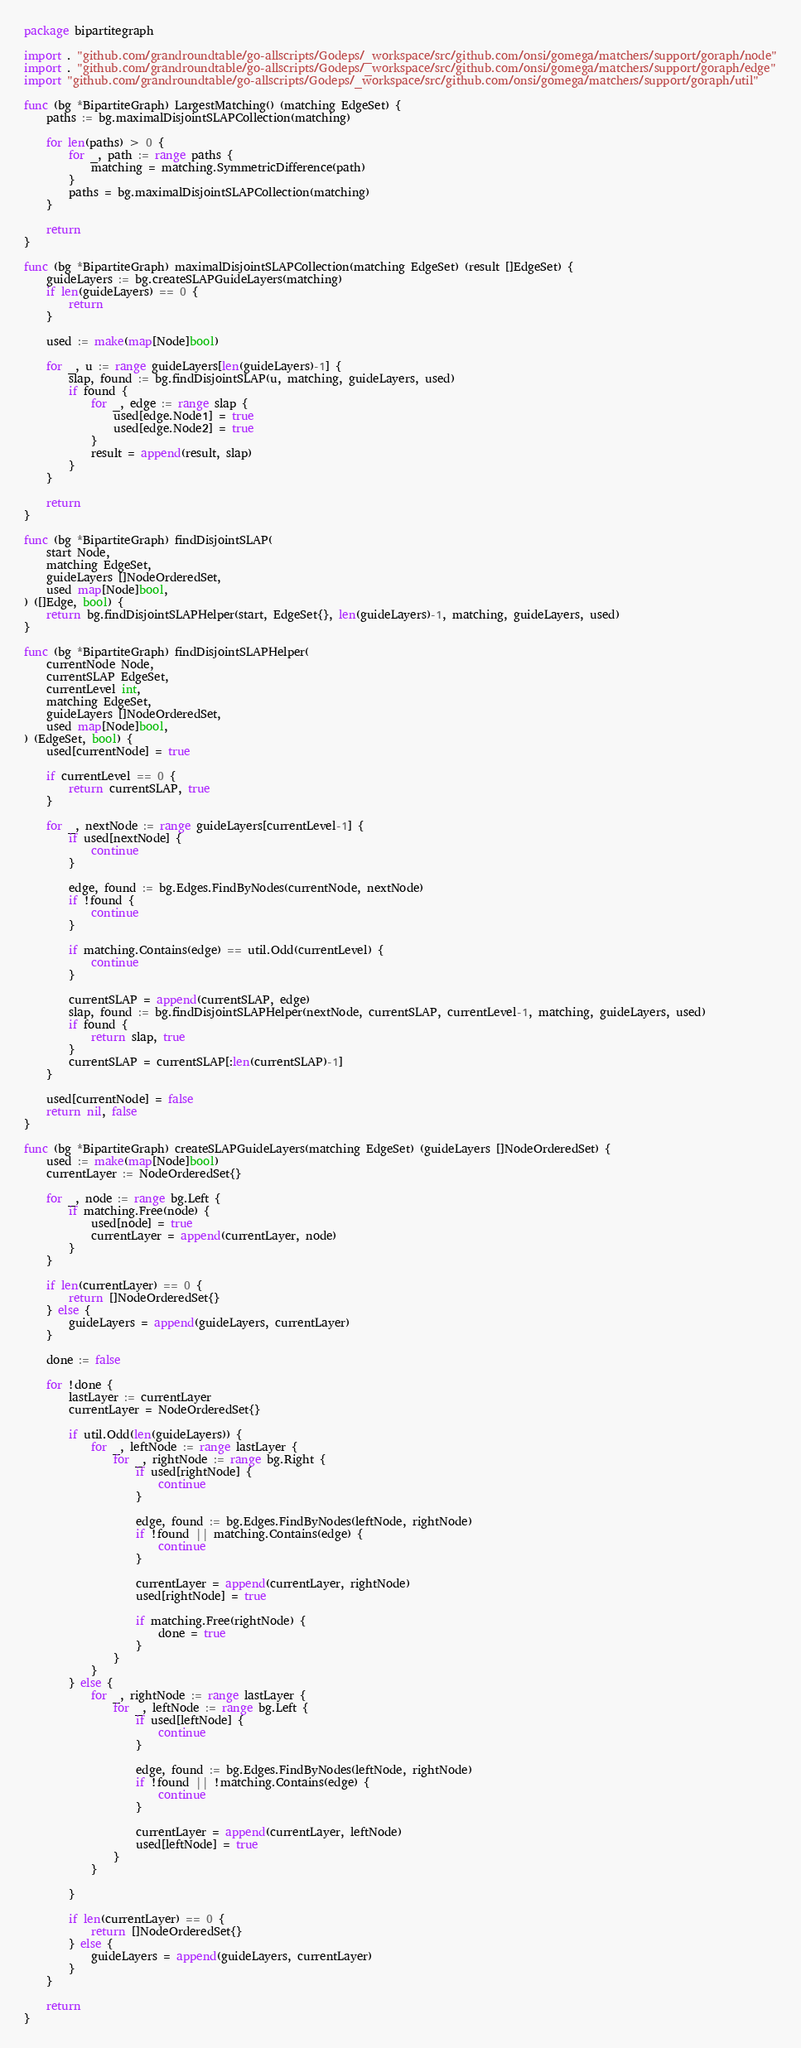Convert code to text. <code><loc_0><loc_0><loc_500><loc_500><_Go_>package bipartitegraph

import . "github.com/grandroundtable/go-allscripts/Godeps/_workspace/src/github.com/onsi/gomega/matchers/support/goraph/node"
import . "github.com/grandroundtable/go-allscripts/Godeps/_workspace/src/github.com/onsi/gomega/matchers/support/goraph/edge"
import "github.com/grandroundtable/go-allscripts/Godeps/_workspace/src/github.com/onsi/gomega/matchers/support/goraph/util"

func (bg *BipartiteGraph) LargestMatching() (matching EdgeSet) {
	paths := bg.maximalDisjointSLAPCollection(matching)

	for len(paths) > 0 {
		for _, path := range paths {
			matching = matching.SymmetricDifference(path)
		}
		paths = bg.maximalDisjointSLAPCollection(matching)
	}

	return
}

func (bg *BipartiteGraph) maximalDisjointSLAPCollection(matching EdgeSet) (result []EdgeSet) {
	guideLayers := bg.createSLAPGuideLayers(matching)
	if len(guideLayers) == 0 {
		return
	}

	used := make(map[Node]bool)

	for _, u := range guideLayers[len(guideLayers)-1] {
		slap, found := bg.findDisjointSLAP(u, matching, guideLayers, used)
		if found {
			for _, edge := range slap {
				used[edge.Node1] = true
				used[edge.Node2] = true
			}
			result = append(result, slap)
		}
	}

	return
}

func (bg *BipartiteGraph) findDisjointSLAP(
	start Node,
	matching EdgeSet,
	guideLayers []NodeOrderedSet,
	used map[Node]bool,
) ([]Edge, bool) {
	return bg.findDisjointSLAPHelper(start, EdgeSet{}, len(guideLayers)-1, matching, guideLayers, used)
}

func (bg *BipartiteGraph) findDisjointSLAPHelper(
	currentNode Node,
	currentSLAP EdgeSet,
	currentLevel int,
	matching EdgeSet,
	guideLayers []NodeOrderedSet,
	used map[Node]bool,
) (EdgeSet, bool) {
	used[currentNode] = true

	if currentLevel == 0 {
		return currentSLAP, true
	}

	for _, nextNode := range guideLayers[currentLevel-1] {
		if used[nextNode] {
			continue
		}

		edge, found := bg.Edges.FindByNodes(currentNode, nextNode)
		if !found {
			continue
		}

		if matching.Contains(edge) == util.Odd(currentLevel) {
			continue
		}

		currentSLAP = append(currentSLAP, edge)
		slap, found := bg.findDisjointSLAPHelper(nextNode, currentSLAP, currentLevel-1, matching, guideLayers, used)
		if found {
			return slap, true
		}
		currentSLAP = currentSLAP[:len(currentSLAP)-1]
	}

	used[currentNode] = false
	return nil, false
}

func (bg *BipartiteGraph) createSLAPGuideLayers(matching EdgeSet) (guideLayers []NodeOrderedSet) {
	used := make(map[Node]bool)
	currentLayer := NodeOrderedSet{}

	for _, node := range bg.Left {
		if matching.Free(node) {
			used[node] = true
			currentLayer = append(currentLayer, node)
		}
	}

	if len(currentLayer) == 0 {
		return []NodeOrderedSet{}
	} else {
		guideLayers = append(guideLayers, currentLayer)
	}

	done := false

	for !done {
		lastLayer := currentLayer
		currentLayer = NodeOrderedSet{}

		if util.Odd(len(guideLayers)) {
			for _, leftNode := range lastLayer {
				for _, rightNode := range bg.Right {
					if used[rightNode] {
						continue
					}

					edge, found := bg.Edges.FindByNodes(leftNode, rightNode)
					if !found || matching.Contains(edge) {
						continue
					}

					currentLayer = append(currentLayer, rightNode)
					used[rightNode] = true

					if matching.Free(rightNode) {
						done = true
					}
				}
			}
		} else {
			for _, rightNode := range lastLayer {
				for _, leftNode := range bg.Left {
					if used[leftNode] {
						continue
					}

					edge, found := bg.Edges.FindByNodes(leftNode, rightNode)
					if !found || !matching.Contains(edge) {
						continue
					}

					currentLayer = append(currentLayer, leftNode)
					used[leftNode] = true
				}
			}

		}

		if len(currentLayer) == 0 {
			return []NodeOrderedSet{}
		} else {
			guideLayers = append(guideLayers, currentLayer)
		}
	}

	return
}
</code> 